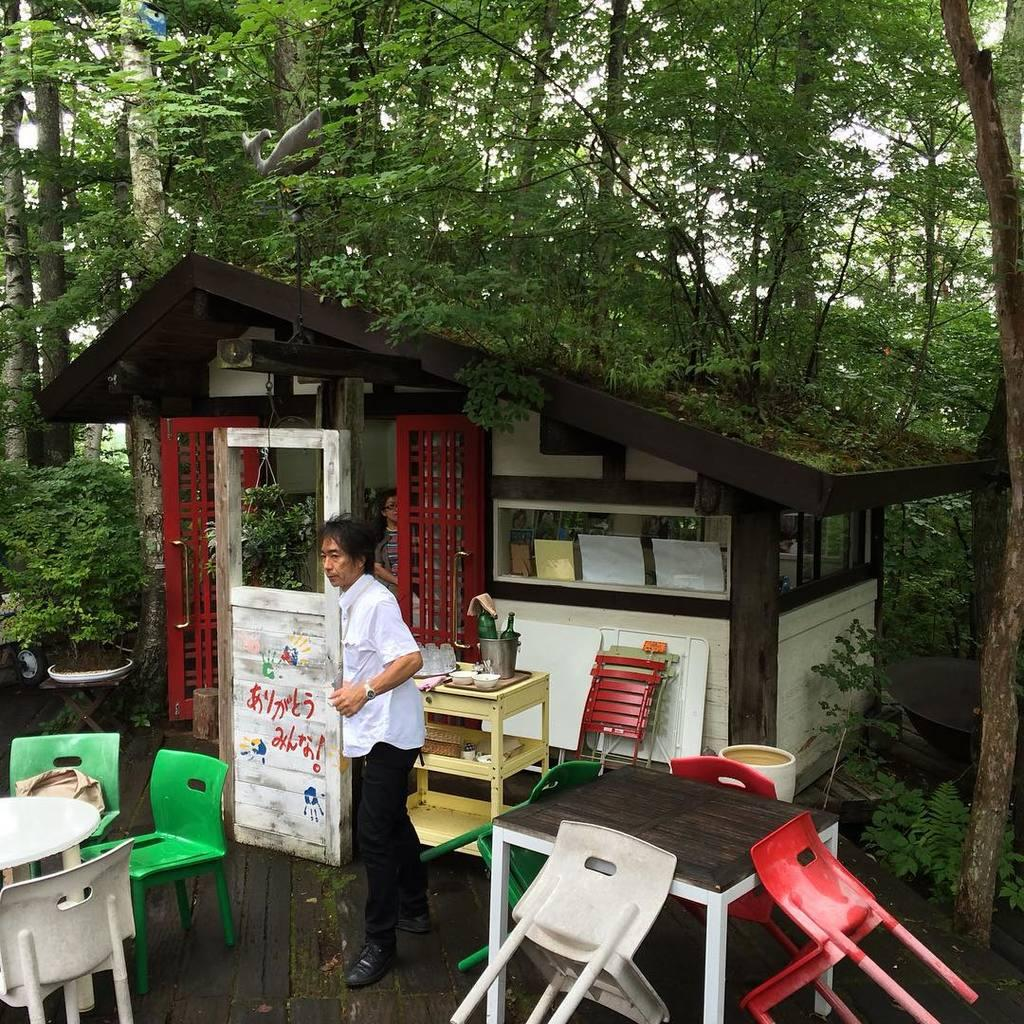What type of vegetation is visible at the top of the image? There are trees at the top of the image. What type of establishment can be seen in the middle of the image? There is a store in the middle of the image. Who or what is located in the middle of the image? There is a person standing in the middle of the image. What type of furniture is visible at the bottom of the image? There are tables and chairs at the bottom of the image. What season is depicted in the image? The provided facts do not mention any seasonal elements, so it cannot be determined from the image. What type of activity is the person engaging in at the store? The provided facts do not mention any specific activity the person is engaging in, so it cannot be determined from the image. 